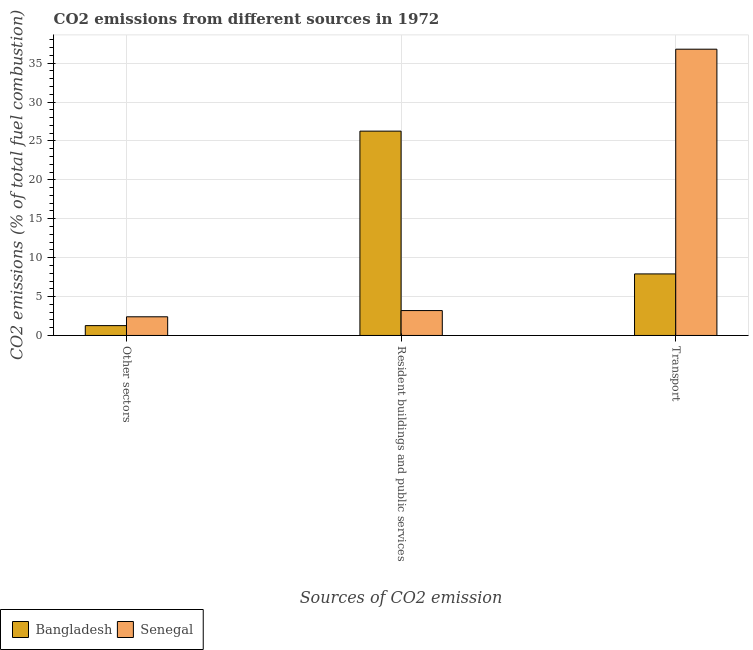How many different coloured bars are there?
Offer a very short reply. 2. How many groups of bars are there?
Provide a succinct answer. 3. Are the number of bars on each tick of the X-axis equal?
Offer a very short reply. Yes. How many bars are there on the 3rd tick from the left?
Provide a short and direct response. 2. How many bars are there on the 3rd tick from the right?
Your response must be concise. 2. What is the label of the 1st group of bars from the left?
Your answer should be compact. Other sectors. What is the percentage of co2 emissions from resident buildings and public services in Bangladesh?
Make the answer very short. 26.27. Across all countries, what is the maximum percentage of co2 emissions from transport?
Your answer should be compact. 36.8. Across all countries, what is the minimum percentage of co2 emissions from other sectors?
Provide a succinct answer. 1.27. In which country was the percentage of co2 emissions from resident buildings and public services minimum?
Your answer should be very brief. Senegal. What is the total percentage of co2 emissions from transport in the graph?
Make the answer very short. 44.71. What is the difference between the percentage of co2 emissions from transport in Senegal and that in Bangladesh?
Your answer should be compact. 28.89. What is the difference between the percentage of co2 emissions from other sectors in Bangladesh and the percentage of co2 emissions from resident buildings and public services in Senegal?
Your response must be concise. -1.93. What is the average percentage of co2 emissions from resident buildings and public services per country?
Keep it short and to the point. 14.73. What is the difference between the percentage of co2 emissions from transport and percentage of co2 emissions from resident buildings and public services in Senegal?
Your answer should be very brief. 33.6. In how many countries, is the percentage of co2 emissions from transport greater than 17 %?
Your answer should be very brief. 1. What is the ratio of the percentage of co2 emissions from transport in Senegal to that in Bangladesh?
Offer a very short reply. 4.65. Is the percentage of co2 emissions from other sectors in Senegal less than that in Bangladesh?
Make the answer very short. No. Is the difference between the percentage of co2 emissions from other sectors in Senegal and Bangladesh greater than the difference between the percentage of co2 emissions from transport in Senegal and Bangladesh?
Give a very brief answer. No. What is the difference between the highest and the second highest percentage of co2 emissions from transport?
Ensure brevity in your answer.  28.89. What is the difference between the highest and the lowest percentage of co2 emissions from other sectors?
Provide a succinct answer. 1.13. What does the 2nd bar from the left in Resident buildings and public services represents?
Make the answer very short. Senegal. Is it the case that in every country, the sum of the percentage of co2 emissions from other sectors and percentage of co2 emissions from resident buildings and public services is greater than the percentage of co2 emissions from transport?
Your answer should be compact. No. How many bars are there?
Your answer should be very brief. 6. How many countries are there in the graph?
Provide a succinct answer. 2. Does the graph contain any zero values?
Provide a succinct answer. No. Where does the legend appear in the graph?
Your response must be concise. Bottom left. How are the legend labels stacked?
Ensure brevity in your answer.  Horizontal. What is the title of the graph?
Keep it short and to the point. CO2 emissions from different sources in 1972. Does "Slovenia" appear as one of the legend labels in the graph?
Offer a very short reply. No. What is the label or title of the X-axis?
Make the answer very short. Sources of CO2 emission. What is the label or title of the Y-axis?
Keep it short and to the point. CO2 emissions (% of total fuel combustion). What is the CO2 emissions (% of total fuel combustion) of Bangladesh in Other sectors?
Offer a very short reply. 1.27. What is the CO2 emissions (% of total fuel combustion) in Senegal in Other sectors?
Provide a short and direct response. 2.4. What is the CO2 emissions (% of total fuel combustion) in Bangladesh in Resident buildings and public services?
Keep it short and to the point. 26.27. What is the CO2 emissions (% of total fuel combustion) of Bangladesh in Transport?
Your answer should be compact. 7.91. What is the CO2 emissions (% of total fuel combustion) in Senegal in Transport?
Your response must be concise. 36.8. Across all Sources of CO2 emission, what is the maximum CO2 emissions (% of total fuel combustion) in Bangladesh?
Provide a succinct answer. 26.27. Across all Sources of CO2 emission, what is the maximum CO2 emissions (% of total fuel combustion) of Senegal?
Your answer should be very brief. 36.8. Across all Sources of CO2 emission, what is the minimum CO2 emissions (% of total fuel combustion) of Bangladesh?
Your response must be concise. 1.27. Across all Sources of CO2 emission, what is the minimum CO2 emissions (% of total fuel combustion) of Senegal?
Make the answer very short. 2.4. What is the total CO2 emissions (% of total fuel combustion) in Bangladesh in the graph?
Keep it short and to the point. 35.44. What is the total CO2 emissions (% of total fuel combustion) of Senegal in the graph?
Your answer should be very brief. 42.4. What is the difference between the CO2 emissions (% of total fuel combustion) in Bangladesh in Other sectors and that in Resident buildings and public services?
Your response must be concise. -25. What is the difference between the CO2 emissions (% of total fuel combustion) of Senegal in Other sectors and that in Resident buildings and public services?
Make the answer very short. -0.8. What is the difference between the CO2 emissions (% of total fuel combustion) in Bangladesh in Other sectors and that in Transport?
Give a very brief answer. -6.65. What is the difference between the CO2 emissions (% of total fuel combustion) in Senegal in Other sectors and that in Transport?
Your answer should be very brief. -34.4. What is the difference between the CO2 emissions (% of total fuel combustion) in Bangladesh in Resident buildings and public services and that in Transport?
Offer a terse response. 18.35. What is the difference between the CO2 emissions (% of total fuel combustion) in Senegal in Resident buildings and public services and that in Transport?
Keep it short and to the point. -33.6. What is the difference between the CO2 emissions (% of total fuel combustion) in Bangladesh in Other sectors and the CO2 emissions (% of total fuel combustion) in Senegal in Resident buildings and public services?
Give a very brief answer. -1.93. What is the difference between the CO2 emissions (% of total fuel combustion) in Bangladesh in Other sectors and the CO2 emissions (% of total fuel combustion) in Senegal in Transport?
Offer a terse response. -35.53. What is the difference between the CO2 emissions (% of total fuel combustion) of Bangladesh in Resident buildings and public services and the CO2 emissions (% of total fuel combustion) of Senegal in Transport?
Your response must be concise. -10.53. What is the average CO2 emissions (% of total fuel combustion) of Bangladesh per Sources of CO2 emission?
Ensure brevity in your answer.  11.81. What is the average CO2 emissions (% of total fuel combustion) in Senegal per Sources of CO2 emission?
Provide a short and direct response. 14.13. What is the difference between the CO2 emissions (% of total fuel combustion) of Bangladesh and CO2 emissions (% of total fuel combustion) of Senegal in Other sectors?
Your answer should be compact. -1.13. What is the difference between the CO2 emissions (% of total fuel combustion) of Bangladesh and CO2 emissions (% of total fuel combustion) of Senegal in Resident buildings and public services?
Your answer should be very brief. 23.07. What is the difference between the CO2 emissions (% of total fuel combustion) in Bangladesh and CO2 emissions (% of total fuel combustion) in Senegal in Transport?
Provide a short and direct response. -28.89. What is the ratio of the CO2 emissions (% of total fuel combustion) of Bangladesh in Other sectors to that in Resident buildings and public services?
Make the answer very short. 0.05. What is the ratio of the CO2 emissions (% of total fuel combustion) in Senegal in Other sectors to that in Resident buildings and public services?
Offer a very short reply. 0.75. What is the ratio of the CO2 emissions (% of total fuel combustion) of Bangladesh in Other sectors to that in Transport?
Make the answer very short. 0.16. What is the ratio of the CO2 emissions (% of total fuel combustion) in Senegal in Other sectors to that in Transport?
Provide a succinct answer. 0.07. What is the ratio of the CO2 emissions (% of total fuel combustion) in Bangladesh in Resident buildings and public services to that in Transport?
Ensure brevity in your answer.  3.32. What is the ratio of the CO2 emissions (% of total fuel combustion) in Senegal in Resident buildings and public services to that in Transport?
Give a very brief answer. 0.09. What is the difference between the highest and the second highest CO2 emissions (% of total fuel combustion) in Bangladesh?
Provide a short and direct response. 18.35. What is the difference between the highest and the second highest CO2 emissions (% of total fuel combustion) in Senegal?
Keep it short and to the point. 33.6. What is the difference between the highest and the lowest CO2 emissions (% of total fuel combustion) in Senegal?
Provide a short and direct response. 34.4. 